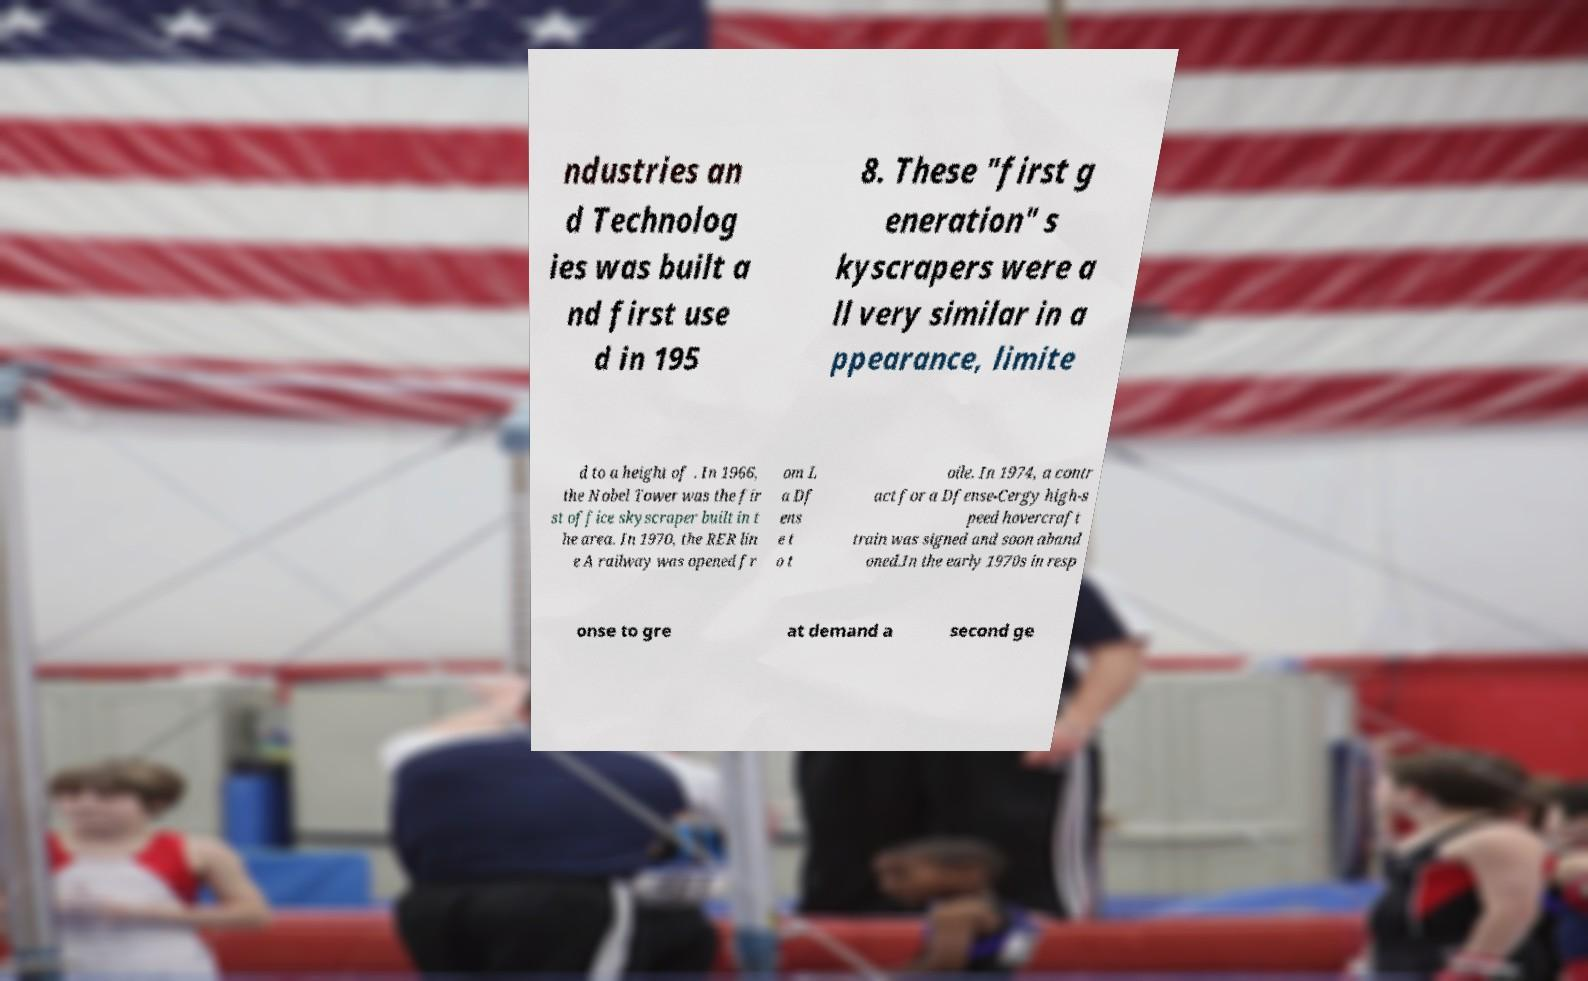For documentation purposes, I need the text within this image transcribed. Could you provide that? ndustries an d Technolog ies was built a nd first use d in 195 8. These "first g eneration" s kyscrapers were a ll very similar in a ppearance, limite d to a height of . In 1966, the Nobel Tower was the fir st office skyscraper built in t he area. In 1970, the RER lin e A railway was opened fr om L a Df ens e t o t oile. In 1974, a contr act for a Dfense-Cergy high-s peed hovercraft train was signed and soon aband oned.In the early 1970s in resp onse to gre at demand a second ge 